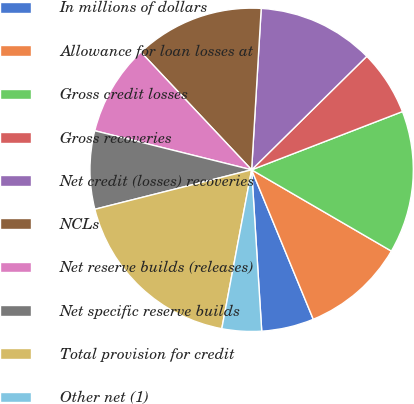Convert chart. <chart><loc_0><loc_0><loc_500><loc_500><pie_chart><fcel>In millions of dollars<fcel>Allowance for loan losses at<fcel>Gross credit losses<fcel>Gross recoveries<fcel>Net credit (losses) recoveries<fcel>NCLs<fcel>Net reserve builds (releases)<fcel>Net specific reserve builds<fcel>Total provision for credit<fcel>Other net (1)<nl><fcel>5.23%<fcel>10.39%<fcel>14.25%<fcel>6.52%<fcel>11.67%<fcel>12.96%<fcel>9.1%<fcel>7.81%<fcel>18.12%<fcel>3.95%<nl></chart> 